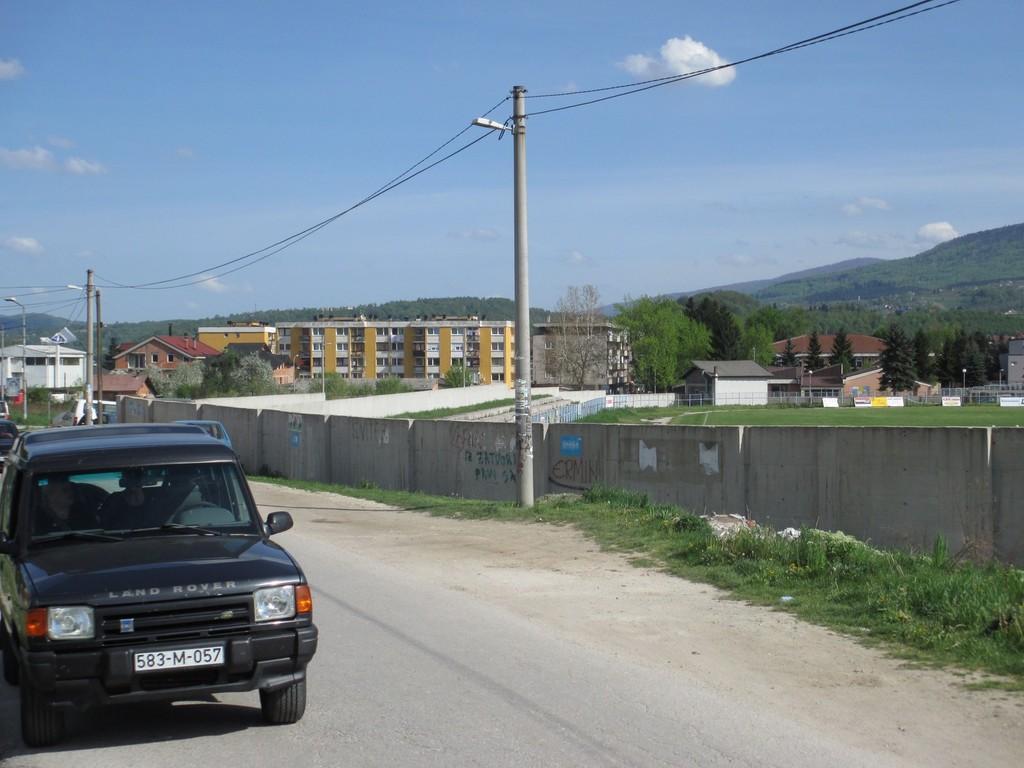Could you give a brief overview of what you see in this image? This image is clicked on the road. To the left there is a car moving on the road. Beside the road there are street light poles and grass on the ground. Behind the poles there is a wall. Behind the wall there's grass on the ground. In the background there are buildings, trees and mountains. At the top there is the sky. 